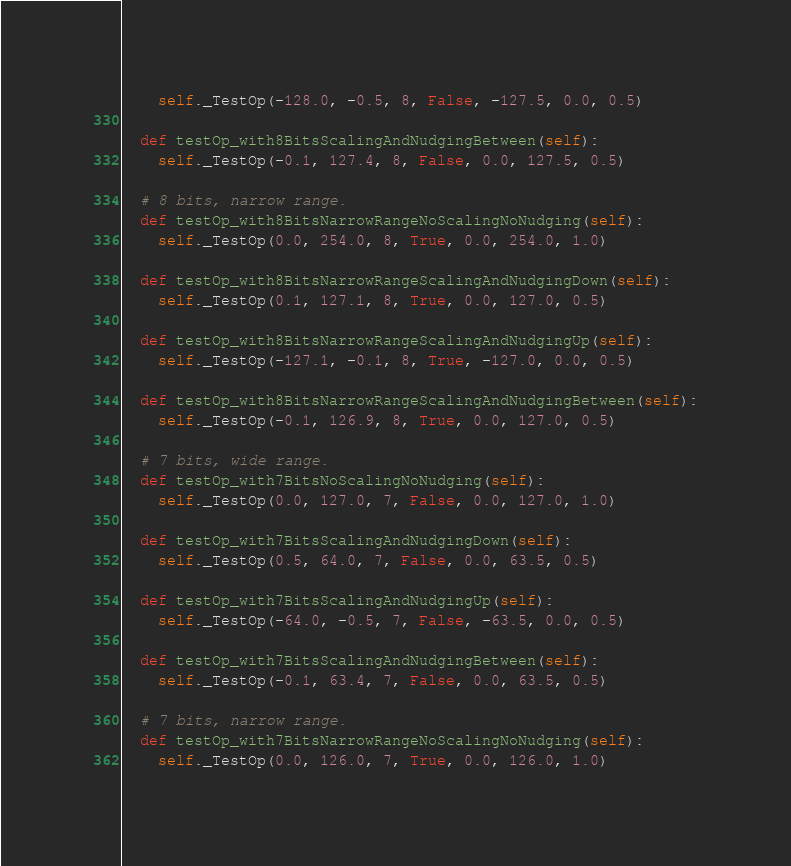<code> <loc_0><loc_0><loc_500><loc_500><_Python_>    self._TestOp(-128.0, -0.5, 8, False, -127.5, 0.0, 0.5)

  def testOp_with8BitsScalingAndNudgingBetween(self):
    self._TestOp(-0.1, 127.4, 8, False, 0.0, 127.5, 0.5)

  # 8 bits, narrow range.
  def testOp_with8BitsNarrowRangeNoScalingNoNudging(self):
    self._TestOp(0.0, 254.0, 8, True, 0.0, 254.0, 1.0)

  def testOp_with8BitsNarrowRangeScalingAndNudgingDown(self):
    self._TestOp(0.1, 127.1, 8, True, 0.0, 127.0, 0.5)

  def testOp_with8BitsNarrowRangeScalingAndNudgingUp(self):
    self._TestOp(-127.1, -0.1, 8, True, -127.0, 0.0, 0.5)

  def testOp_with8BitsNarrowRangeScalingAndNudgingBetween(self):
    self._TestOp(-0.1, 126.9, 8, True, 0.0, 127.0, 0.5)

  # 7 bits, wide range.
  def testOp_with7BitsNoScalingNoNudging(self):
    self._TestOp(0.0, 127.0, 7, False, 0.0, 127.0, 1.0)

  def testOp_with7BitsScalingAndNudgingDown(self):
    self._TestOp(0.5, 64.0, 7, False, 0.0, 63.5, 0.5)

  def testOp_with7BitsScalingAndNudgingUp(self):
    self._TestOp(-64.0, -0.5, 7, False, -63.5, 0.0, 0.5)

  def testOp_with7BitsScalingAndNudgingBetween(self):
    self._TestOp(-0.1, 63.4, 7, False, 0.0, 63.5, 0.5)

  # 7 bits, narrow range.
  def testOp_with7BitsNarrowRangeNoScalingNoNudging(self):
    self._TestOp(0.0, 126.0, 7, True, 0.0, 126.0, 1.0)
</code> 